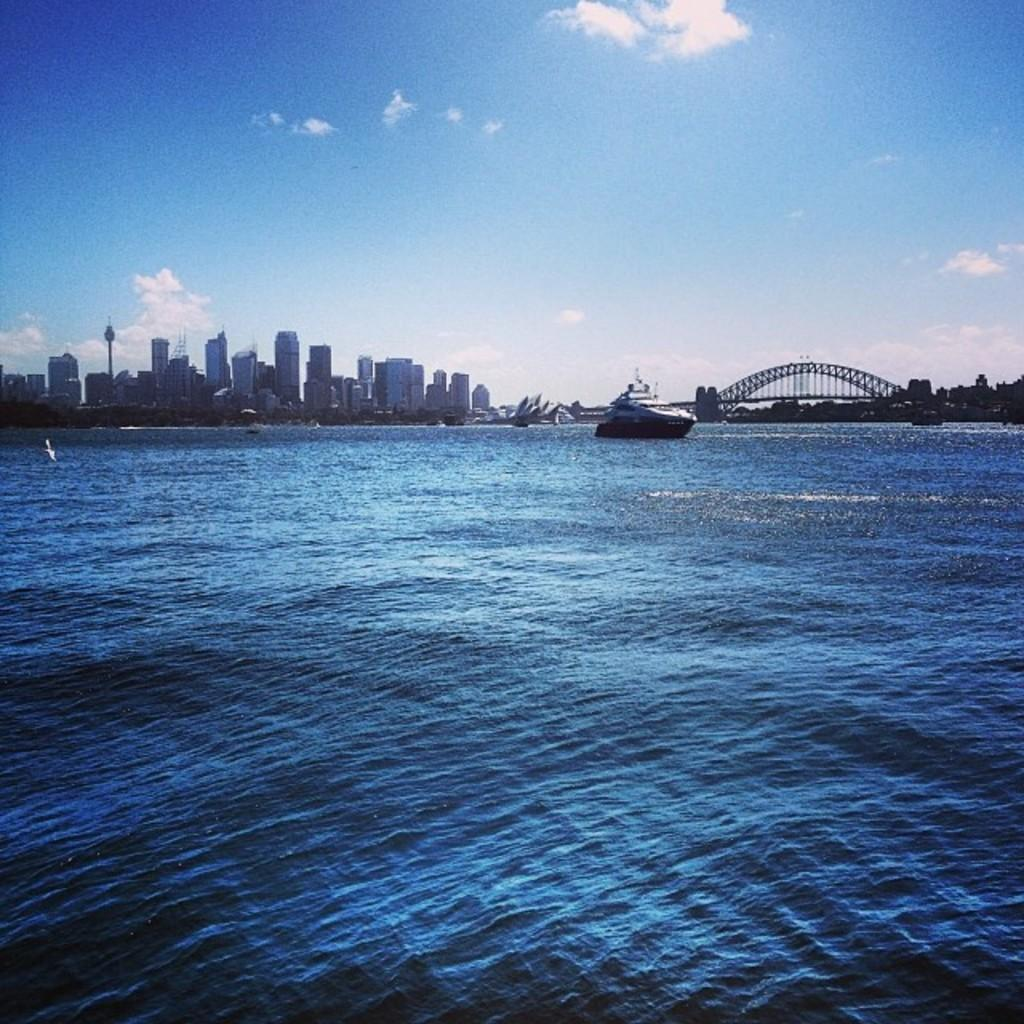What is the main subject in the water in the image? There is a ship in the water in the image. What structure can be seen in the image? There is a bridge in the image. What type of vegetation is present in the image? There are trees in the image. What can be seen in the background of the image? There is a skyline view of buildings in the image. What type of protest is happening near the ship in the image? There is no protest visible in the image; it only features a ship, a bridge, trees, and buildings. 